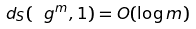<formula> <loc_0><loc_0><loc_500><loc_500>d _ { S } ( \ g ^ { m } , 1 ) = O ( \log m )</formula> 